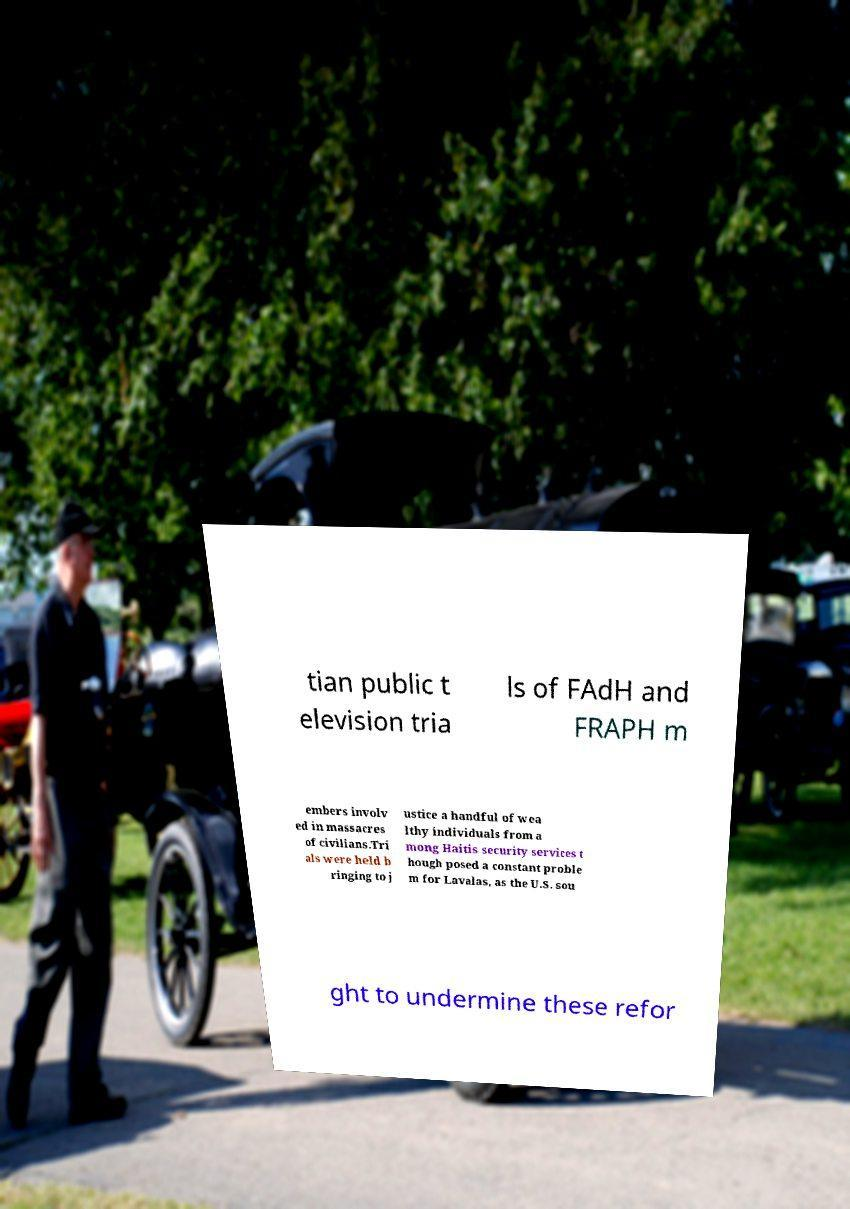For documentation purposes, I need the text within this image transcribed. Could you provide that? tian public t elevision tria ls of FAdH and FRAPH m embers involv ed in massacres of civilians.Tri als were held b ringing to j ustice a handful of wea lthy individuals from a mong Haitis security services t hough posed a constant proble m for Lavalas, as the U.S. sou ght to undermine these refor 